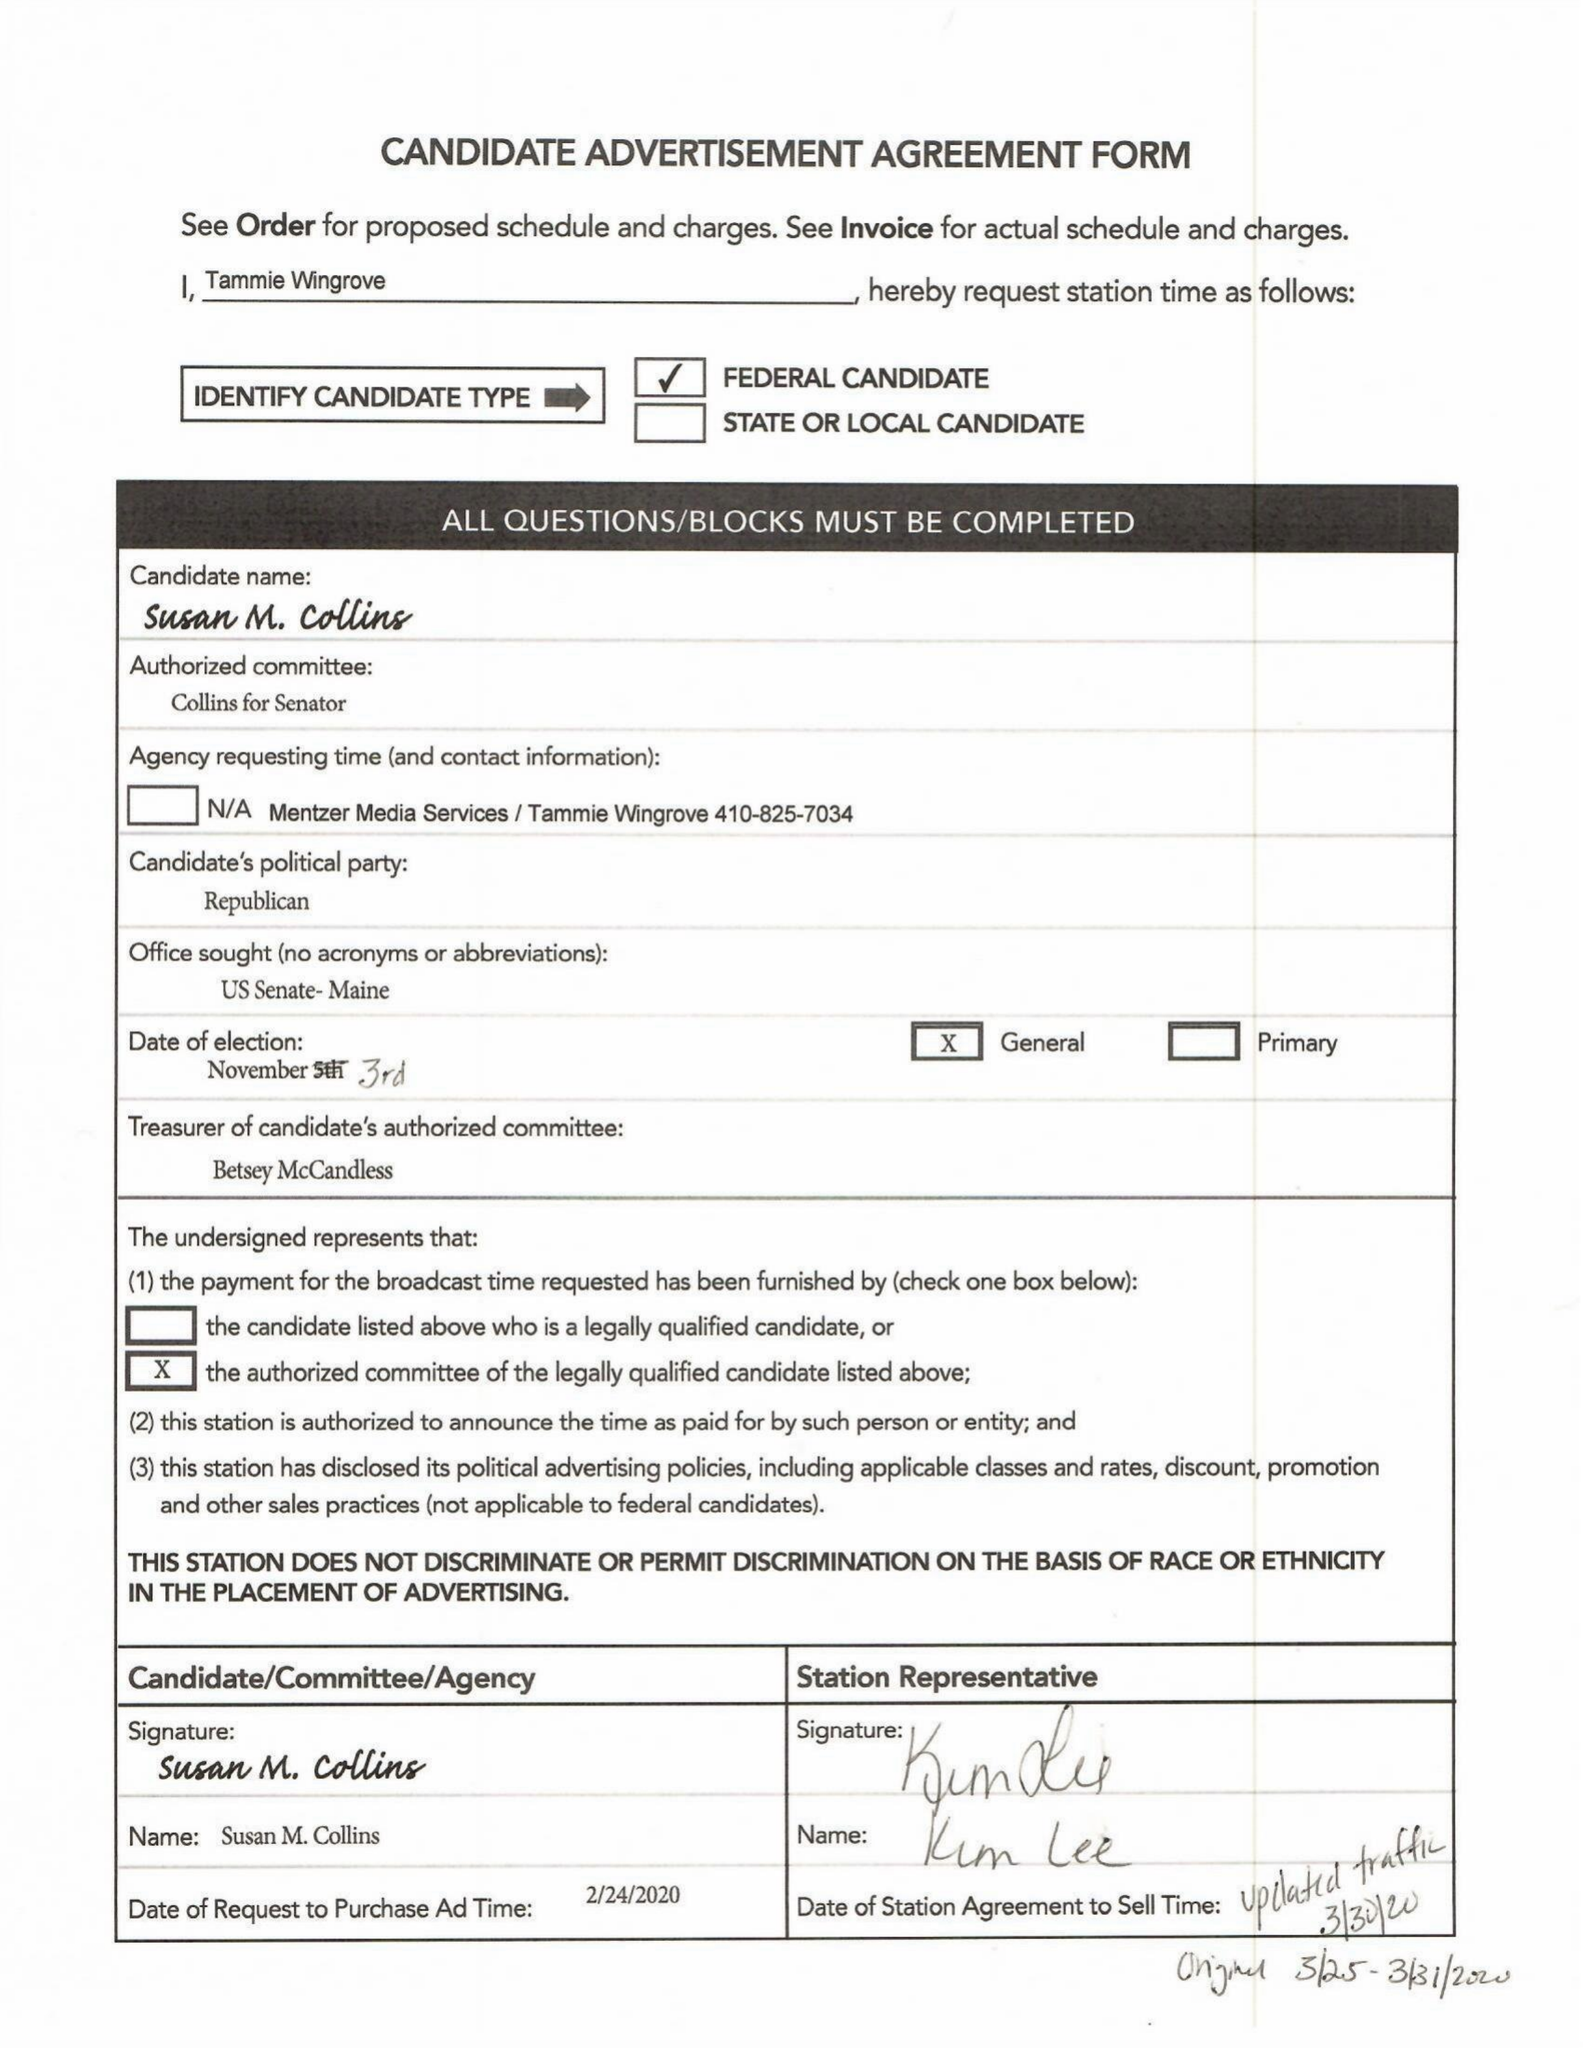What is the value for the flight_from?
Answer the question using a single word or phrase. 03/31/20 